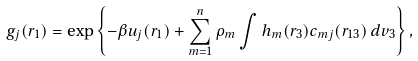<formula> <loc_0><loc_0><loc_500><loc_500>g _ { j } ( { r } _ { 1 } ) = \exp \left \{ - \beta u _ { j } ( { r } _ { 1 } ) + \sum _ { m = 1 } ^ { n } \rho _ { m } \int h _ { m } ( { r } _ { 3 } ) c _ { m j } ( { r } _ { 1 3 } ) \, d { v } _ { 3 } \right \} ,</formula> 